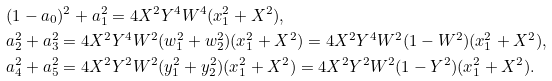<formula> <loc_0><loc_0><loc_500><loc_500>& ( 1 - a _ { 0 } ) ^ { 2 } + a _ { 1 } ^ { 2 } = 4 X ^ { 2 } Y ^ { 4 } W ^ { 4 } ( x _ { 1 } ^ { 2 } + X ^ { 2 } ) , \\ & a _ { 2 } ^ { 2 } + a _ { 3 } ^ { 2 } = 4 X ^ { 2 } Y ^ { 4 } W ^ { 2 } ( w _ { 1 } ^ { 2 } + w _ { 2 } ^ { 2 } ) ( x _ { 1 } ^ { 2 } + X ^ { 2 } ) = 4 X ^ { 2 } Y ^ { 4 } W ^ { 2 } ( 1 - W ^ { 2 } ) ( x _ { 1 } ^ { 2 } + X ^ { 2 } ) , \\ & a _ { 4 } ^ { 2 } + a _ { 5 } ^ { 2 } = 4 X ^ { 2 } Y ^ { 2 } W ^ { 2 } ( y _ { 1 } ^ { 2 } + y _ { 2 } ^ { 2 } ) ( x _ { 1 } ^ { 2 } + X ^ { 2 } ) = 4 X ^ { 2 } Y ^ { 2 } W ^ { 2 } ( 1 - Y ^ { 2 } ) ( x _ { 1 } ^ { 2 } + X ^ { 2 } ) .</formula> 